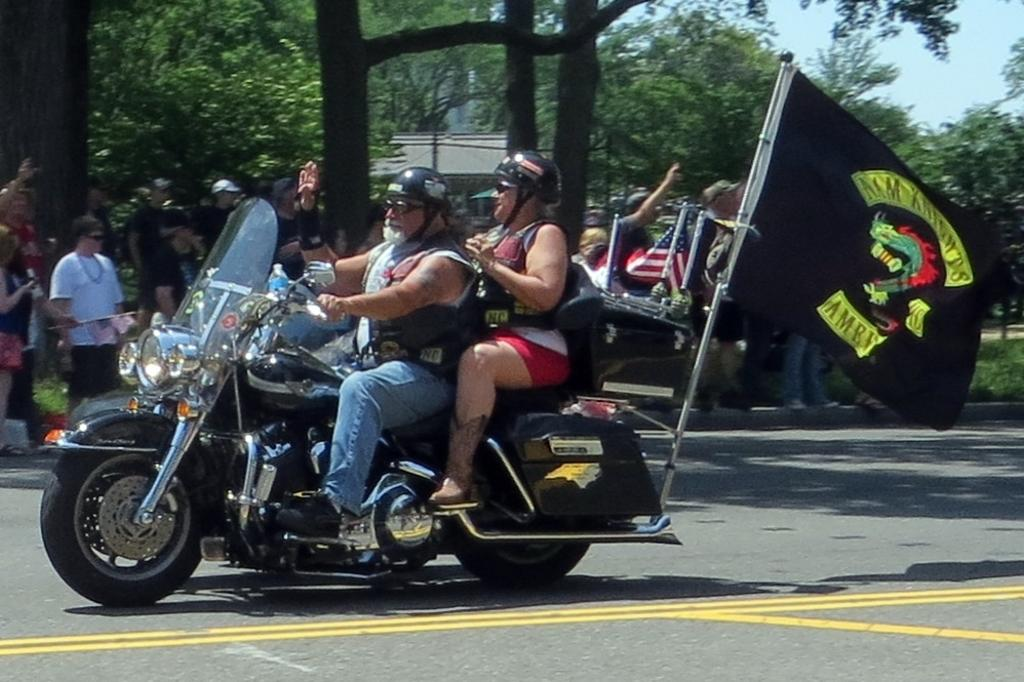What is the man doing in the image? The man is riding a motorcycle in the image. Who is with the man on the motorcycle? There is a woman sitting on the back of the motorcycle. What can be seen in the distance in the image? There are trees visible in the background of the image. What type of peace symbol can be seen on the edge of the motorcycle in the image? There is no peace symbol or any other symbol present on the motorcycle in the image. How many stars are visible on the woman's shirt in the image? There is no information about the woman's shirt or any stars in the image. 